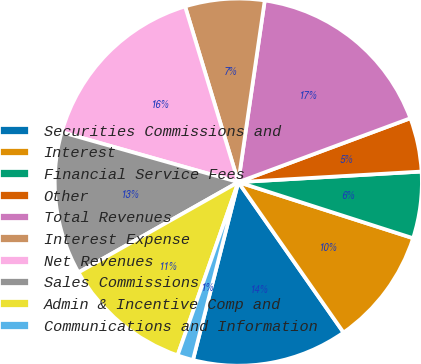<chart> <loc_0><loc_0><loc_500><loc_500><pie_chart><fcel>Securities Commissions and<fcel>Interest<fcel>Financial Service Fees<fcel>Other<fcel>Total Revenues<fcel>Interest Expense<fcel>Net Revenues<fcel>Sales Commissions<fcel>Admin & Incentive Comp and<fcel>Communications and Information<nl><fcel>13.69%<fcel>10.34%<fcel>5.86%<fcel>4.74%<fcel>17.04%<fcel>6.98%<fcel>15.93%<fcel>12.57%<fcel>11.45%<fcel>1.39%<nl></chart> 